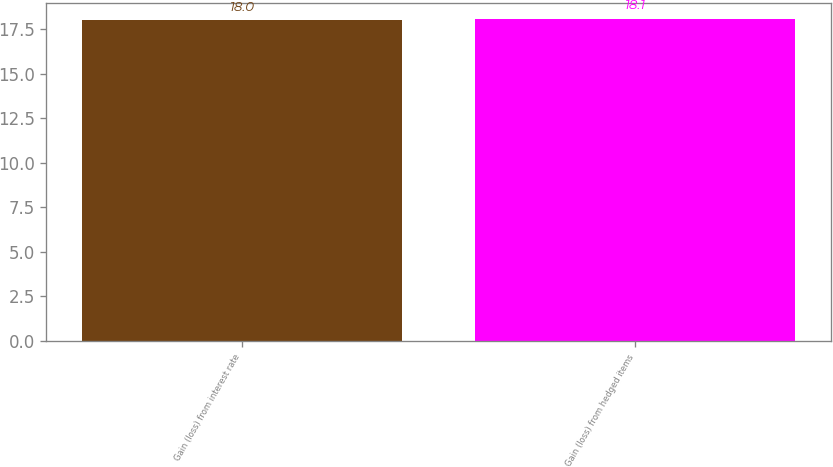Convert chart. <chart><loc_0><loc_0><loc_500><loc_500><bar_chart><fcel>Gain (loss) from interest rate<fcel>Gain (loss) from hedged items<nl><fcel>18<fcel>18.1<nl></chart> 